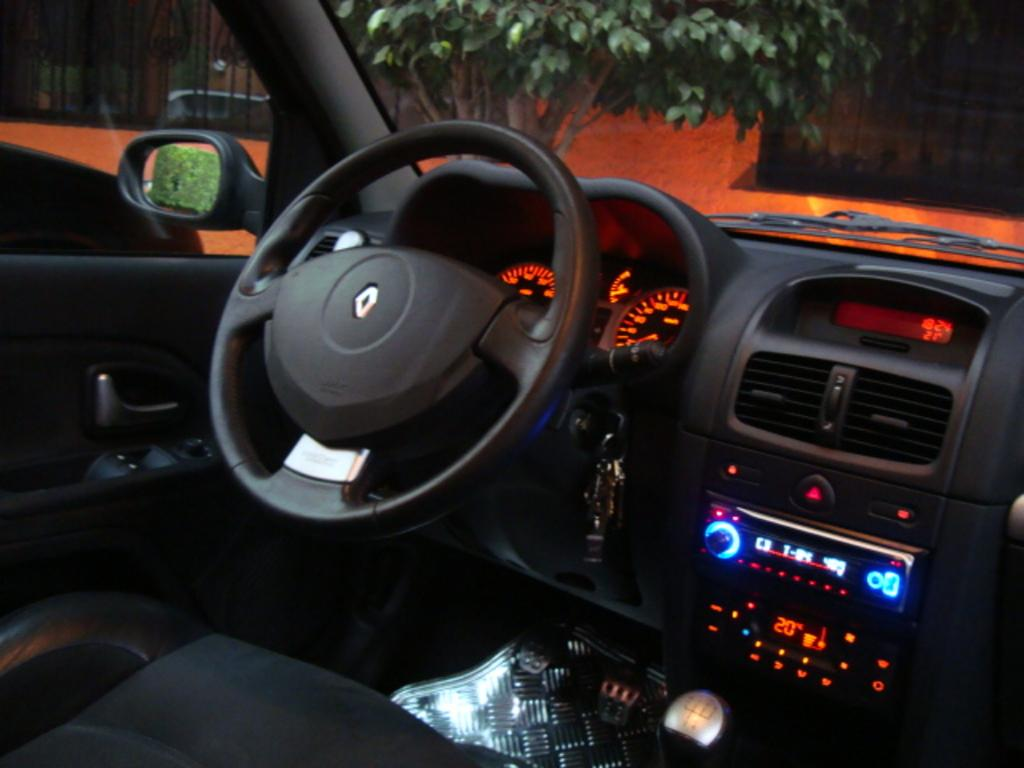Where was the image taken? The image was taken inside a car. What can be seen in the driver's area of the car? There is a steering wheel, a mirror, glass, a wiper, a speedometer, keys, a brake, and an accelerator in the image. What type of quince is hanging from the rearview mirror in the image? There is no quince present in the image; the mirror is the only object mentioned in the driver's area. Can you hear the sound of a bee buzzing in the image? There is no sound present in the image, as it is a still photograph. 